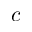Convert formula to latex. <formula><loc_0><loc_0><loc_500><loc_500>c</formula> 